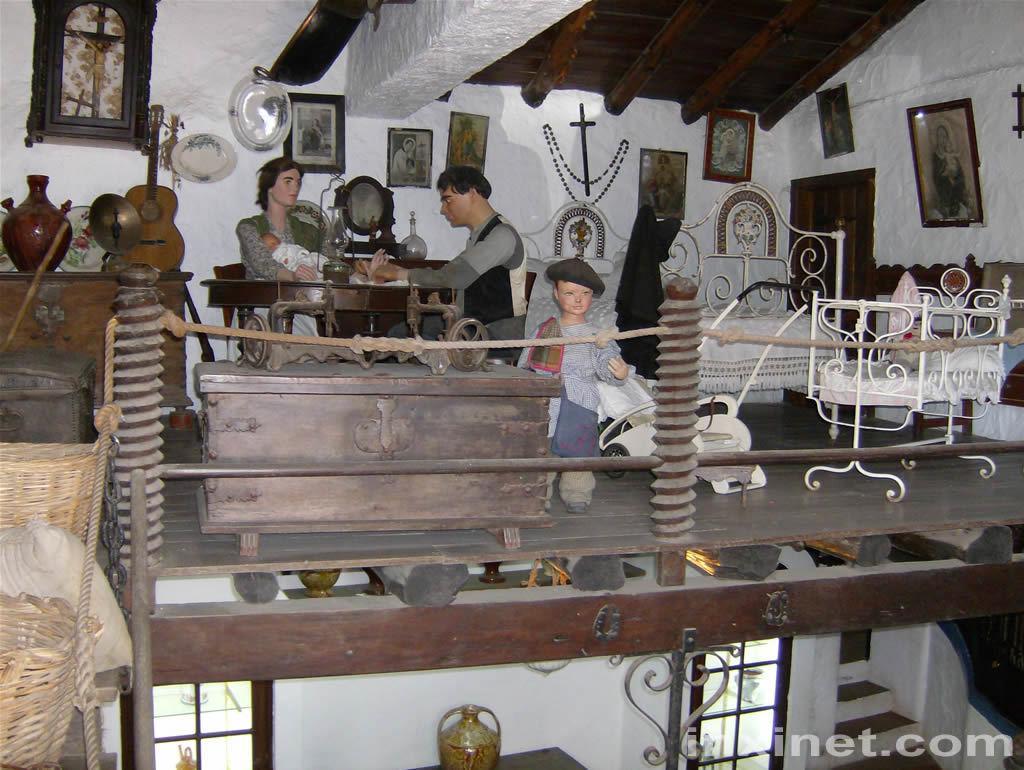Describe this image in one or two sentences. This image looks like sculptures. There are two persons sitting on the chairs. This is a small boy. This looks like abed. these are the photo frames attached to the wall. I can see a violin, a pot placed on the table. This looks like a wooden box. I think this is at the rooftop. 